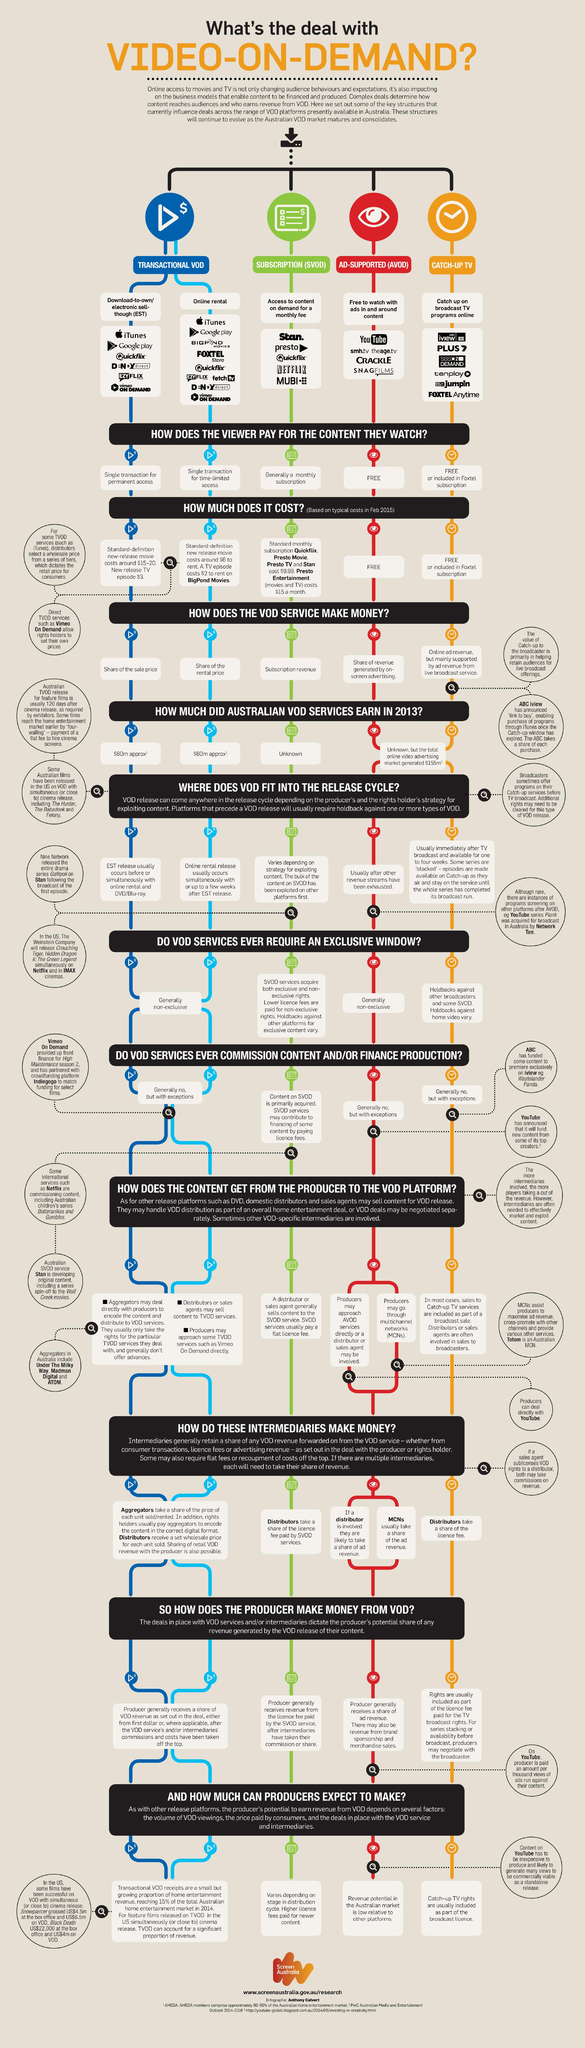Outline some significant characteristics in this image. YouTube is an example of a video-on-demand service that operates on an advertising-supported (AVOD) business model. YouTube generates revenue by sharing a portion of the advertising revenue generated by on-screen advertisements displayed on its platform. I declare that the VOD (Video On Demand) service is free to watch and is ad-supported (AVOD) The fourth type of Video on Demand listed in the infographic is Catch-Up TV. It is normal for VOD services to not be exclusive to only three. 